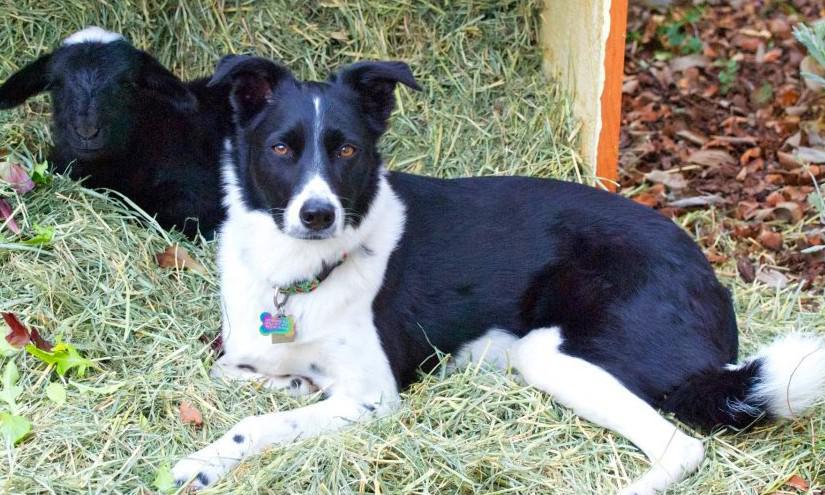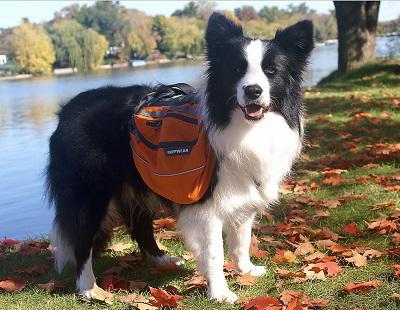The first image is the image on the left, the second image is the image on the right. Examine the images to the left and right. Is the description "There is a diagonal, rod-like dark object near at least one reclining dog." accurate? Answer yes or no. No. 